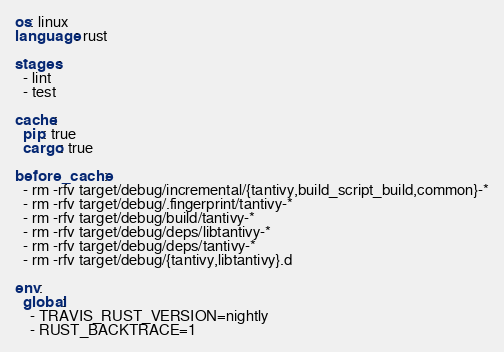<code> <loc_0><loc_0><loc_500><loc_500><_YAML_>os: linux
language: rust

stages:
  - lint
  - test

cache:
  pip: true
  cargo: true

before_cache:
  - rm -rfv target/debug/incremental/{tantivy,build_script_build,common}-*
  - rm -rfv target/debug/.fingerprint/tantivy-*
  - rm -rfv target/debug/build/tantivy-*
  - rm -rfv target/debug/deps/libtantivy-*
  - rm -rfv target/debug/deps/tantivy-*
  - rm -rfv target/debug/{tantivy,libtantivy}.d

env:
  global:
    - TRAVIS_RUST_VERSION=nightly
    - RUST_BACKTRACE=1</code> 